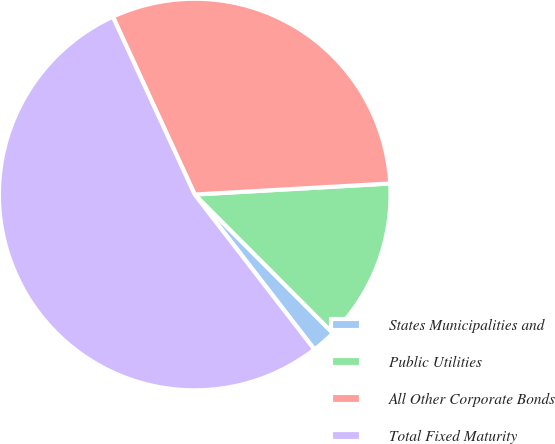Convert chart to OTSL. <chart><loc_0><loc_0><loc_500><loc_500><pie_chart><fcel>States Municipalities and<fcel>Public Utilities<fcel>All Other Corporate Bonds<fcel>Total Fixed Maturity<nl><fcel>2.01%<fcel>13.42%<fcel>30.97%<fcel>53.6%<nl></chart> 